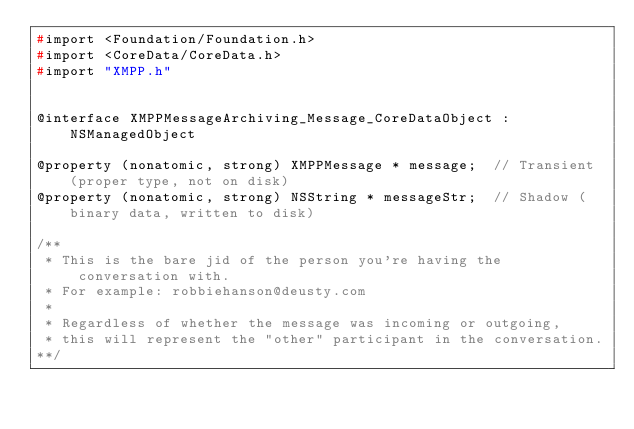Convert code to text. <code><loc_0><loc_0><loc_500><loc_500><_C_>#import <Foundation/Foundation.h>
#import <CoreData/CoreData.h>
#import "XMPP.h"


@interface XMPPMessageArchiving_Message_CoreDataObject : NSManagedObject

@property (nonatomic, strong) XMPPMessage * message;  // Transient (proper type, not on disk)
@property (nonatomic, strong) NSString * messageStr;  // Shadow (binary data, written to disk)

/**
 * This is the bare jid of the person you're having the conversation with.
 * For example: robbiehanson@deusty.com
 * 
 * Regardless of whether the message was incoming or outgoing,
 * this will represent the "other" participant in the conversation.
**/</code> 